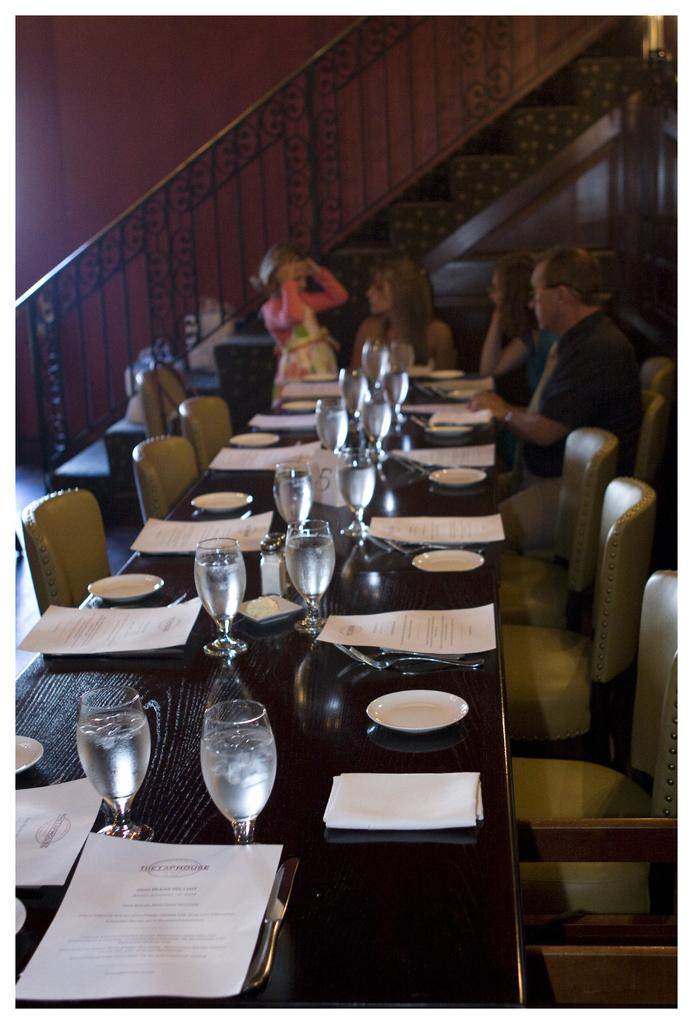What are the people in the image doing? The persons in the image are sitting on chairs. What is present on the table in the image? There are glasses, plates, and papers on the table. What is the primary piece of furniture in the image? There is a table in the image. What can be seen in the background of the image? There is a wall in the background of the image. What channel are the children watching on the television in the image? There is no television or children present in the image. 